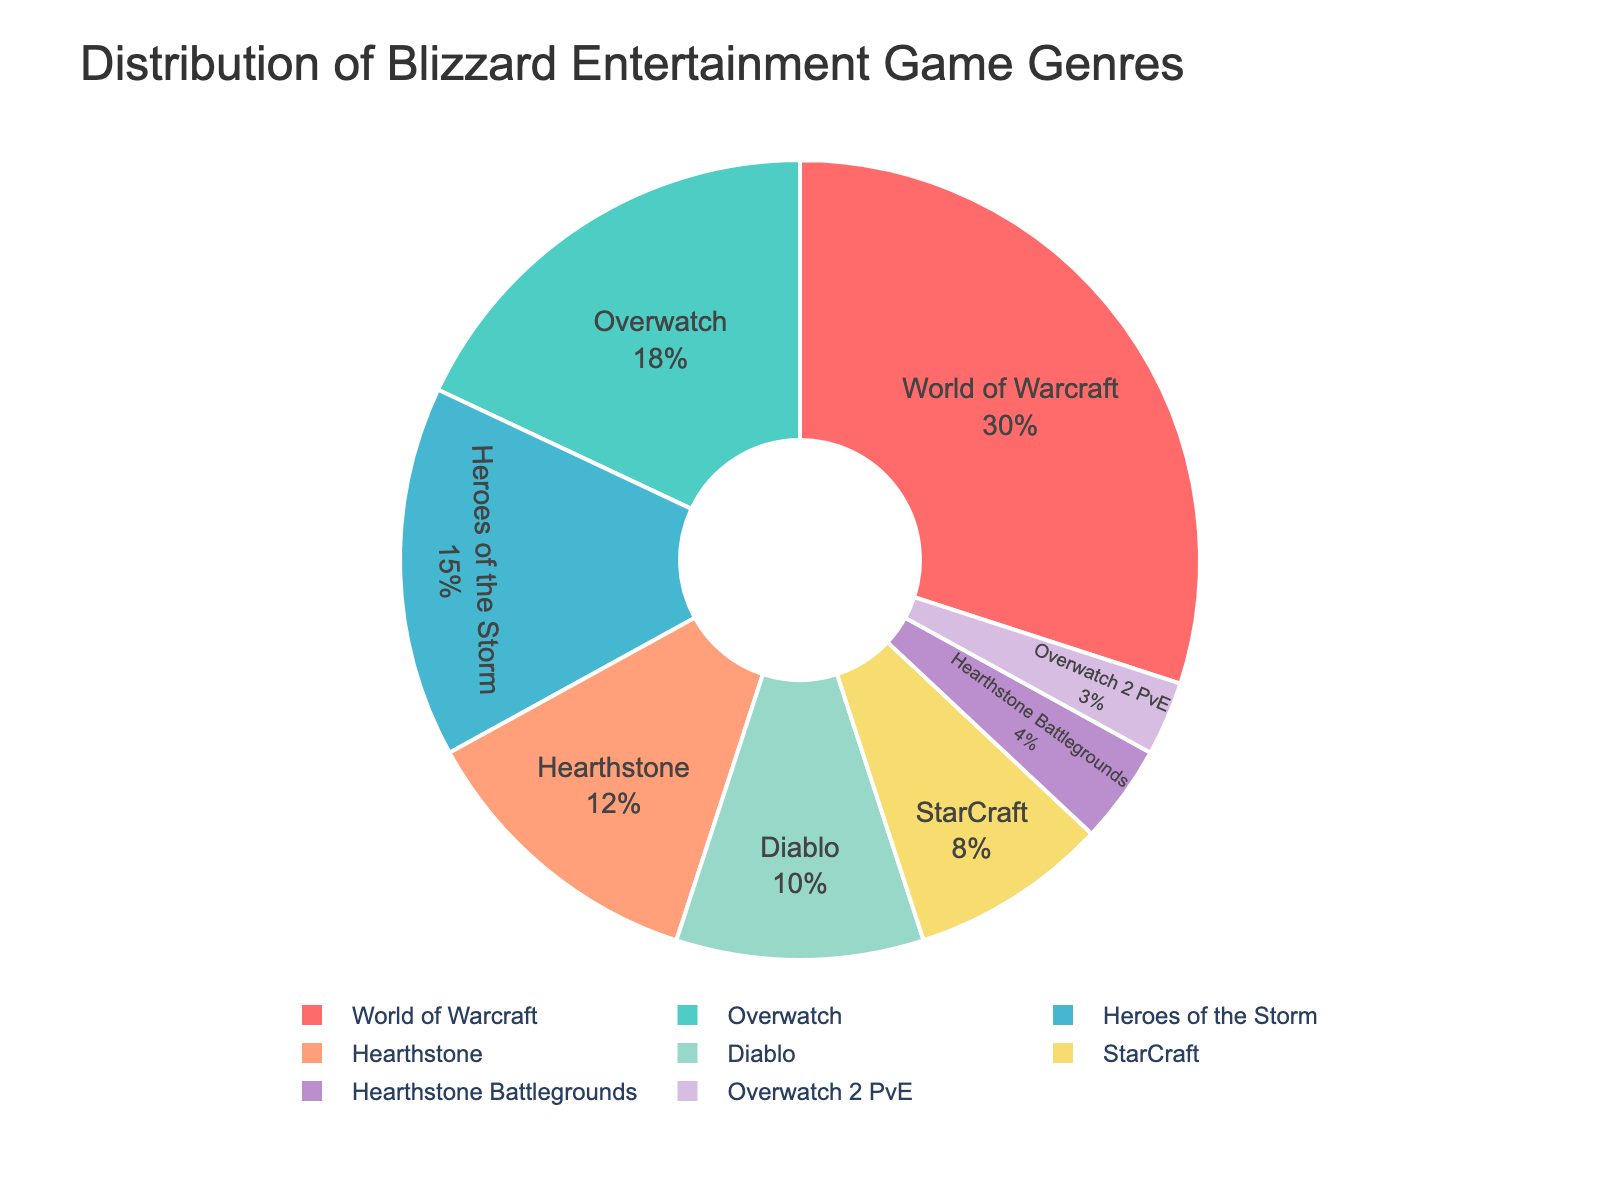Which game franchise has the largest share? By looking at the pie chart, we can see the franchise with the largest sector. This sector has the largest area and thus represents the highest percentage.
Answer: World of Warcraft How much larger is the share of World of Warcraft compared to Diablo? World of Warcraft has a 30% share while Diablo has a 10% share. The difference is calculated as 30% - 10% = 20%
Answer: 20% Which genres have a share smaller than 10%? We need to identify the segments with less than 10% in the pie chart. These sectors are relatively smaller compared to others.
Answer: StarCraft, Hearthstone Battlegrounds, Overwatch 2 PvE What is the combined percentage share of Hearthstone and Hearthstone Battlegrounds? Add the percentages for both Hearthstone (12%) and Hearthstone Battlegrounds (4%). The combined percentage is 12% + 4% = 16%
Answer: 16% Which genre is represented by the purple color in the pie chart? Look at the pie chart and identify the segment colored in purple.
Answer: StarCraft How does the percentage share of Overwatch compare to Heroes of the Storm? By comparing the sectors in the pie chart, Overwatch has an 18% share and Heroes of the Storm has a 15% share. Overwatch's share is greater than Heroes of the Storm's by 18% - 15% = 3%
Answer: Overwatch has 3% more share What percentage of the chart does the Auto Battler genre take up? Identify the sector labeled Hearthstone Battlegrounds, which represents the Auto Battler genre, and note its percentage.
Answer: 4% What is the visual difference between the MMO RPG genre and the Survival genre? The MMO RPG genre (World of Warcraft) has the largest sector with 30%, while the Survival genre (Overwatch 2 PvE) has one of the smallest sectors with 3%. Visually, the MMO RPG genre sector is significantly larger than the Survival genre sector.
Answer: MMO RPG has a much larger sector Which genre has a larger share: CCG or ARPG? Compare the CCG (Hearthstone) segment size, 12%, with the ARPG (Diablo) segment size, 10%. The CCG segment is larger.
Answer: CCG 